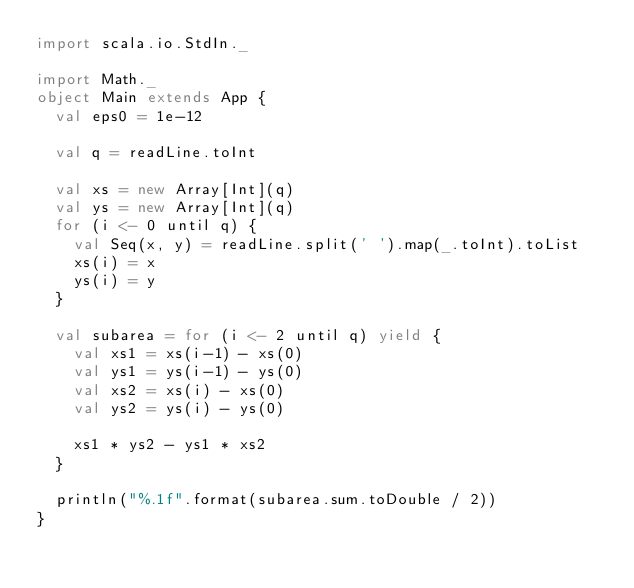Convert code to text. <code><loc_0><loc_0><loc_500><loc_500><_Scala_>import scala.io.StdIn._

import Math._
object Main extends App {
  val eps0 = 1e-12

  val q = readLine.toInt

  val xs = new Array[Int](q)
  val ys = new Array[Int](q)
  for (i <- 0 until q) {
    val Seq(x, y) = readLine.split(' ').map(_.toInt).toList
    xs(i) = x
    ys(i) = y
  }

  val subarea = for (i <- 2 until q) yield {
    val xs1 = xs(i-1) - xs(0)
    val ys1 = ys(i-1) - ys(0)
    val xs2 = xs(i) - xs(0)
    val ys2 = ys(i) - ys(0)

    xs1 * ys2 - ys1 * xs2
  }

  println("%.1f".format(subarea.sum.toDouble / 2))
}
</code> 